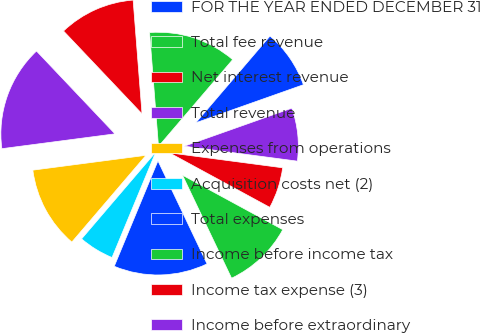Convert chart. <chart><loc_0><loc_0><loc_500><loc_500><pie_chart><fcel>FOR THE YEAR ENDED DECEMBER 31<fcel>Total fee revenue<fcel>Net interest revenue<fcel>Total revenue<fcel>Expenses from operations<fcel>Acquisition costs net (2)<fcel>Total expenses<fcel>Income before income tax<fcel>Income tax expense (3)<fcel>Income before extraordinary<nl><fcel>8.33%<fcel>12.5%<fcel>10.83%<fcel>15.0%<fcel>11.67%<fcel>5.0%<fcel>13.33%<fcel>10.0%<fcel>5.83%<fcel>7.5%<nl></chart> 